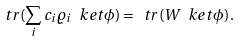Convert formula to latex. <formula><loc_0><loc_0><loc_500><loc_500>\ t r ( \sum _ { i } c _ { i } \varrho _ { i } \ k e t { \phi } ) = \ t r ( W \ k e t { \phi } ) \, .</formula> 